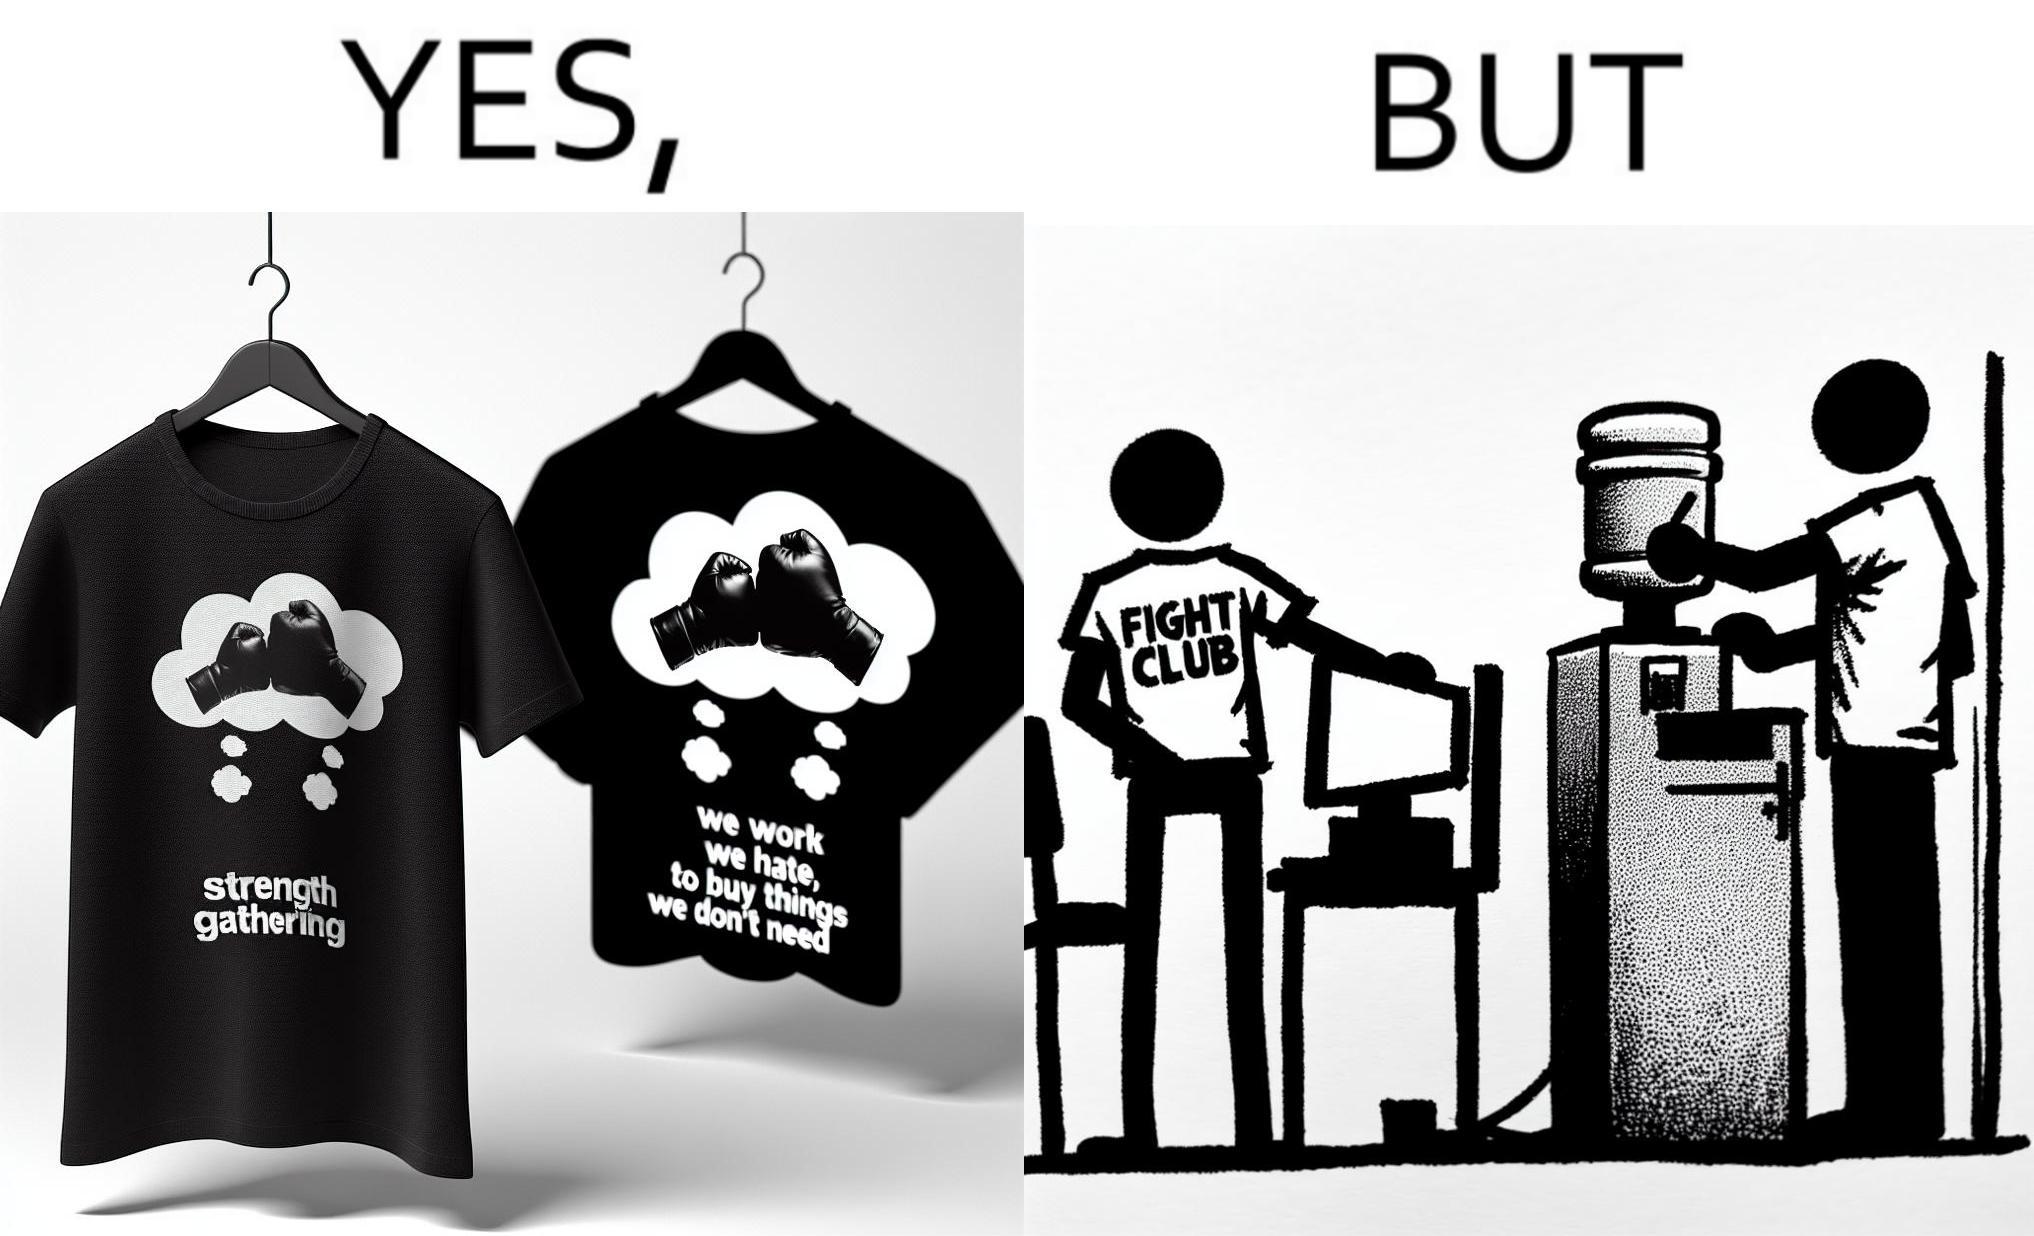Describe the contrast between the left and right parts of this image. In the left part of the image: a t-shirt with "Fight Club" written on it (referring to the movie), along with a dialogue from the movie that says "We work jobs we hate, to buy sh*t we don't need". In the right part of the image: a person wearing a t-shirt that says "Fight Club", working on a computer system, with a water dispenser by the side. 